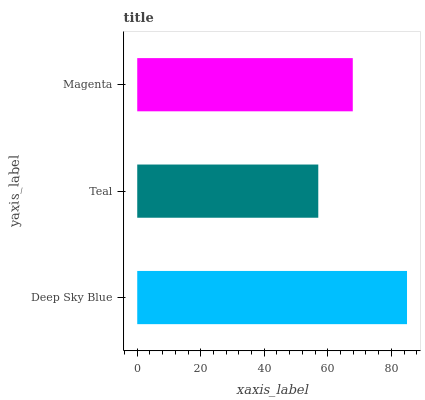Is Teal the minimum?
Answer yes or no. Yes. Is Deep Sky Blue the maximum?
Answer yes or no. Yes. Is Magenta the minimum?
Answer yes or no. No. Is Magenta the maximum?
Answer yes or no. No. Is Magenta greater than Teal?
Answer yes or no. Yes. Is Teal less than Magenta?
Answer yes or no. Yes. Is Teal greater than Magenta?
Answer yes or no. No. Is Magenta less than Teal?
Answer yes or no. No. Is Magenta the high median?
Answer yes or no. Yes. Is Magenta the low median?
Answer yes or no. Yes. Is Teal the high median?
Answer yes or no. No. Is Teal the low median?
Answer yes or no. No. 